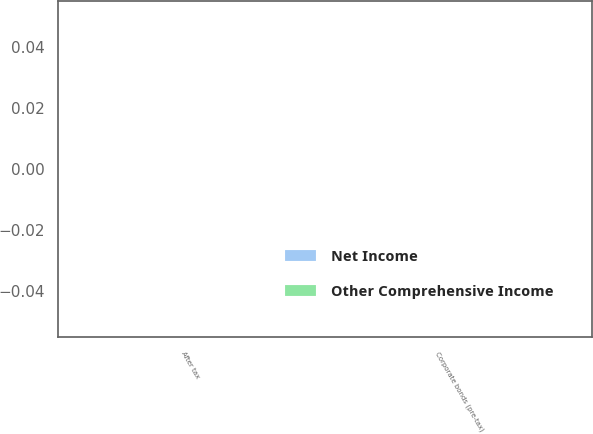<chart> <loc_0><loc_0><loc_500><loc_500><stacked_bar_chart><ecel><fcel>Corporate bonds (pre-tax)<fcel>After tax<nl><fcel>Other Comprehensive Income<fcel>0<fcel>0<nl><fcel>Net Income<fcel>0<fcel>0<nl></chart> 